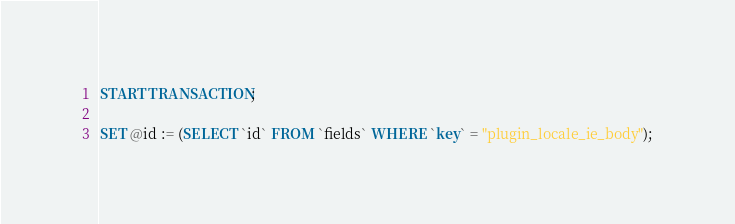Convert code to text. <code><loc_0><loc_0><loc_500><loc_500><_SQL_>
START TRANSACTION;

SET @id := (SELECT `id` FROM `fields` WHERE `key` = "plugin_locale_ie_body");</code> 